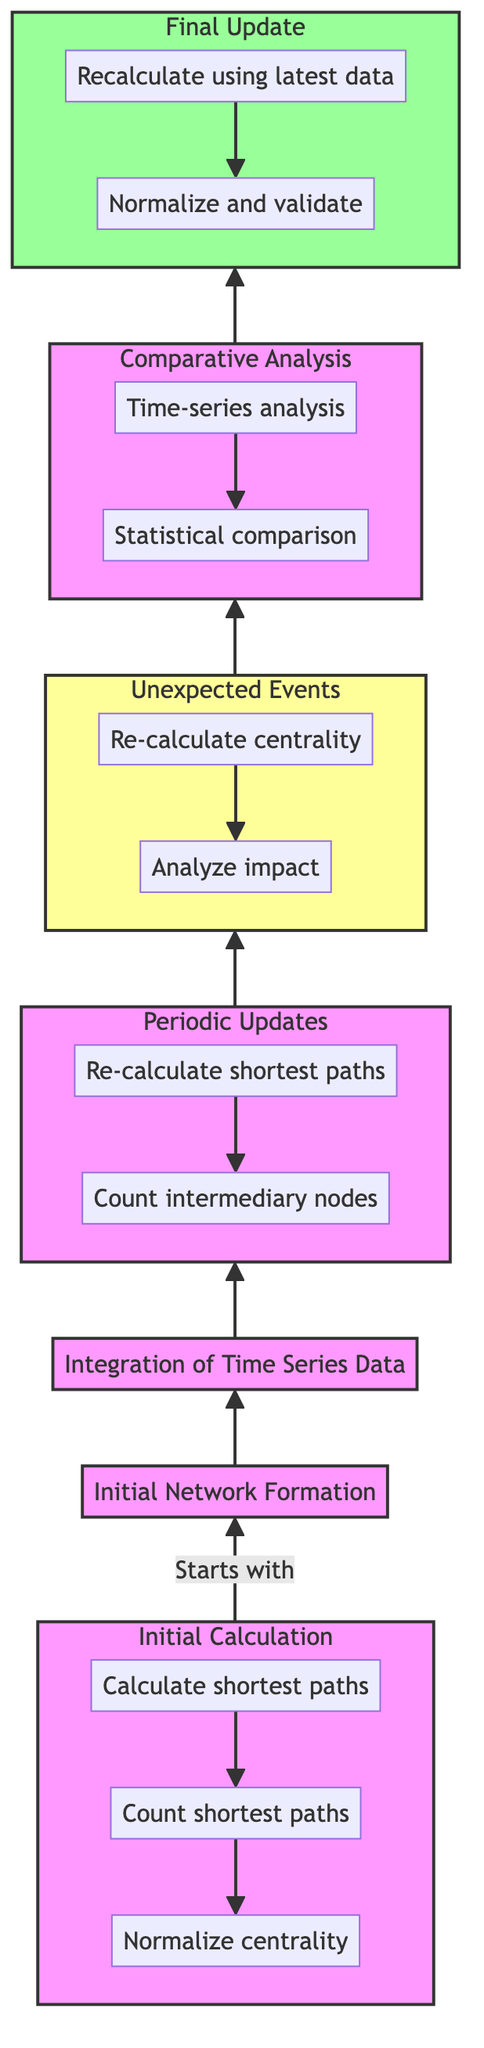What initiates the flow in this diagram? The flow in the diagram starts with the "Initial Calculation" block, which is the first step in the process.
Answer: Initial Calculation How many activities are listed under the "Initial Calculation" node? The "Initial Calculation" node contains three activities: calculating shortest paths, counting shortest paths, and normalizing centrality values.
Answer: Three What is the cycle of updates described in the "Periodic Updates" section? The "Periodic Updates" section specifies a monthly cycle for updating betweenness centrality.
Answer: Monthly Which node has a distinct style compared to the others? The "Unexpected Events" node is highlighted with an eventStyle class, differentiating it visually from other nodes.
Answer: Unexpected Events What follows the "Comparative Analysis" in the flow? The flow continues from "Comparative Analysis" to the "Final Update" node, indicating the progression of steps.
Answer: Final Update What are the two main methods listed under "Periodic Updates"? The methods in the "Periodic Updates" section are re-calculating shortest paths and counting intermediary nodes in the new network.
Answer: Re-calculate shortest paths and count intermediary nodes What is the main description of the "Final Update" node? The "Final Update" node is primarily focused on conducting final recalculations and confirming the latest betweenness centrality values.
Answer: Conduct final recalculations How many sub-nodes are in the "Unexpected Events" section? The "Unexpected Events" section includes two sub-nodes, which detail the activities related to recalculating centrality and analyzing impact.
Answer: Two What type of analysis is performed in the "Comparative Analysis" section? The analysis types mentioned in the "Comparative Analysis" section are time-series analysis and statistical comparison, indicating a focus on comparison over time.
Answer: Time-series analysis and statistical comparison 